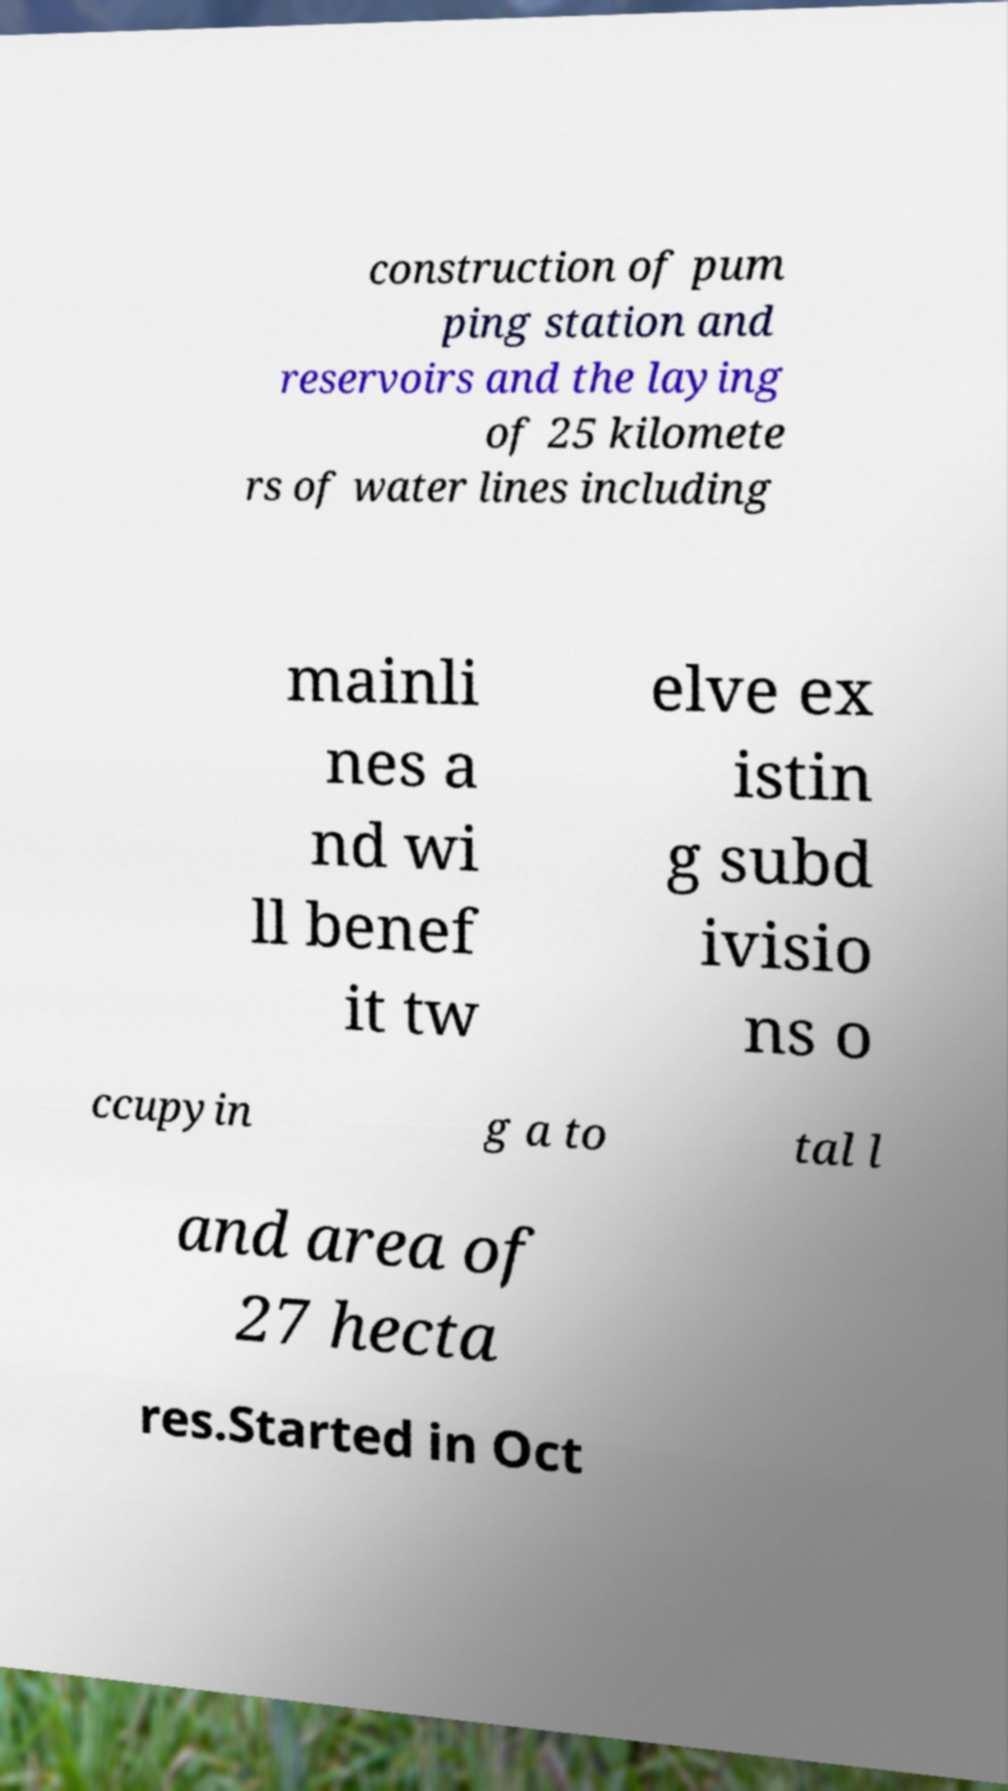I need the written content from this picture converted into text. Can you do that? construction of pum ping station and reservoirs and the laying of 25 kilomete rs of water lines including mainli nes a nd wi ll benef it tw elve ex istin g subd ivisio ns o ccupyin g a to tal l and area of 27 hecta res.Started in Oct 